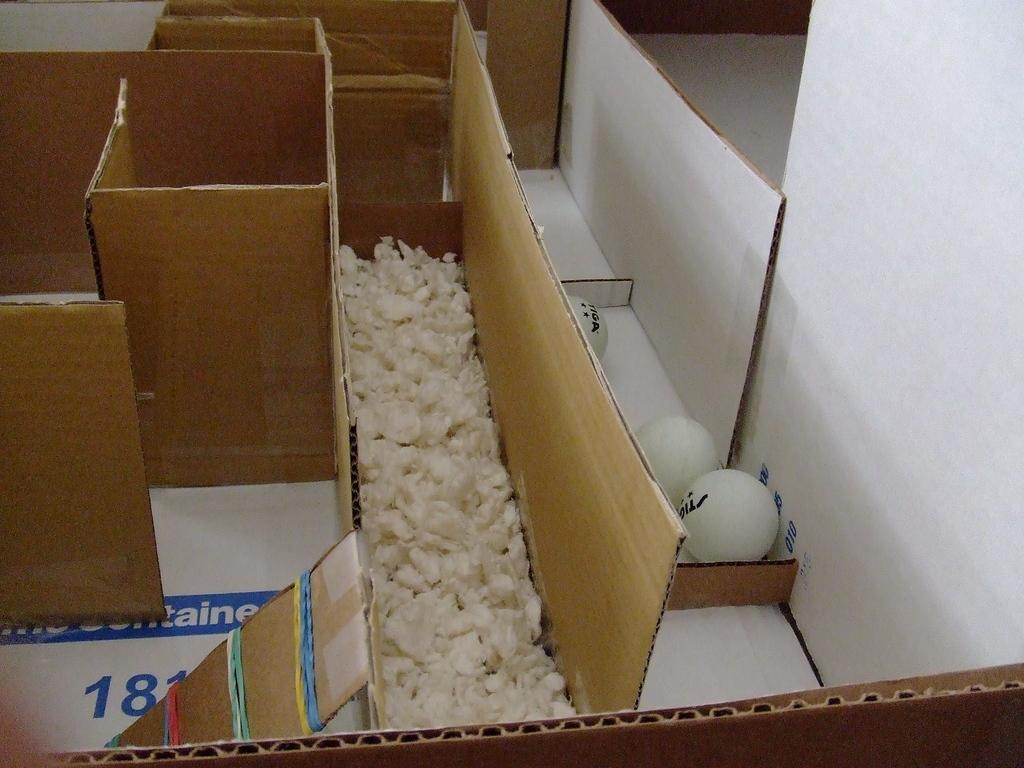Provide a one-sentence caption for the provided image. Packages in a puzzle formats of Tiga brand balls. 